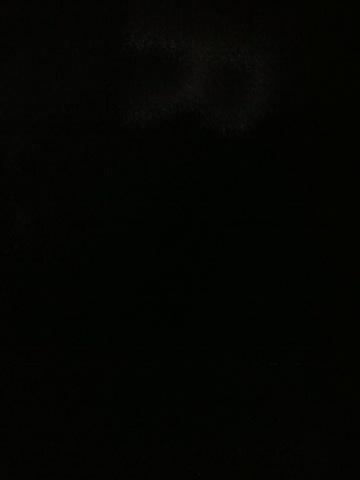This might be a snapshot of a night sky. Can you tell me what's there? If this image were a snapshot of the night sky, one could expect to see stars dotting the vast expanse. Perhaps the faint glow of distant galaxies or the Milky Way stretching across the sky. Though the image is mostly dark, sometimes patience and a keen eye can reveal celestial wonders hidden in the night. 